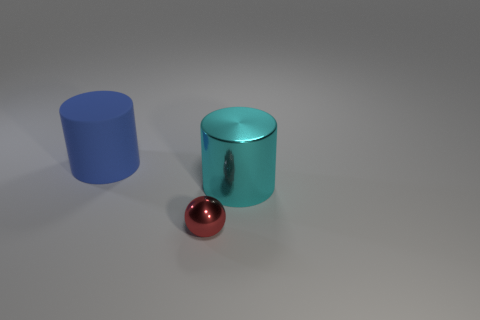Subtract all balls. How many objects are left? 2 Add 1 cylinders. How many objects exist? 4 Subtract 1 blue cylinders. How many objects are left? 2 Subtract 1 cylinders. How many cylinders are left? 1 Subtract all green cylinders. Subtract all yellow spheres. How many cylinders are left? 2 Subtract all yellow cylinders. How many gray balls are left? 0 Subtract all red objects. Subtract all red spheres. How many objects are left? 1 Add 1 cyan cylinders. How many cyan cylinders are left? 2 Add 3 small brown metal cylinders. How many small brown metal cylinders exist? 3 Subtract all blue cylinders. How many cylinders are left? 1 